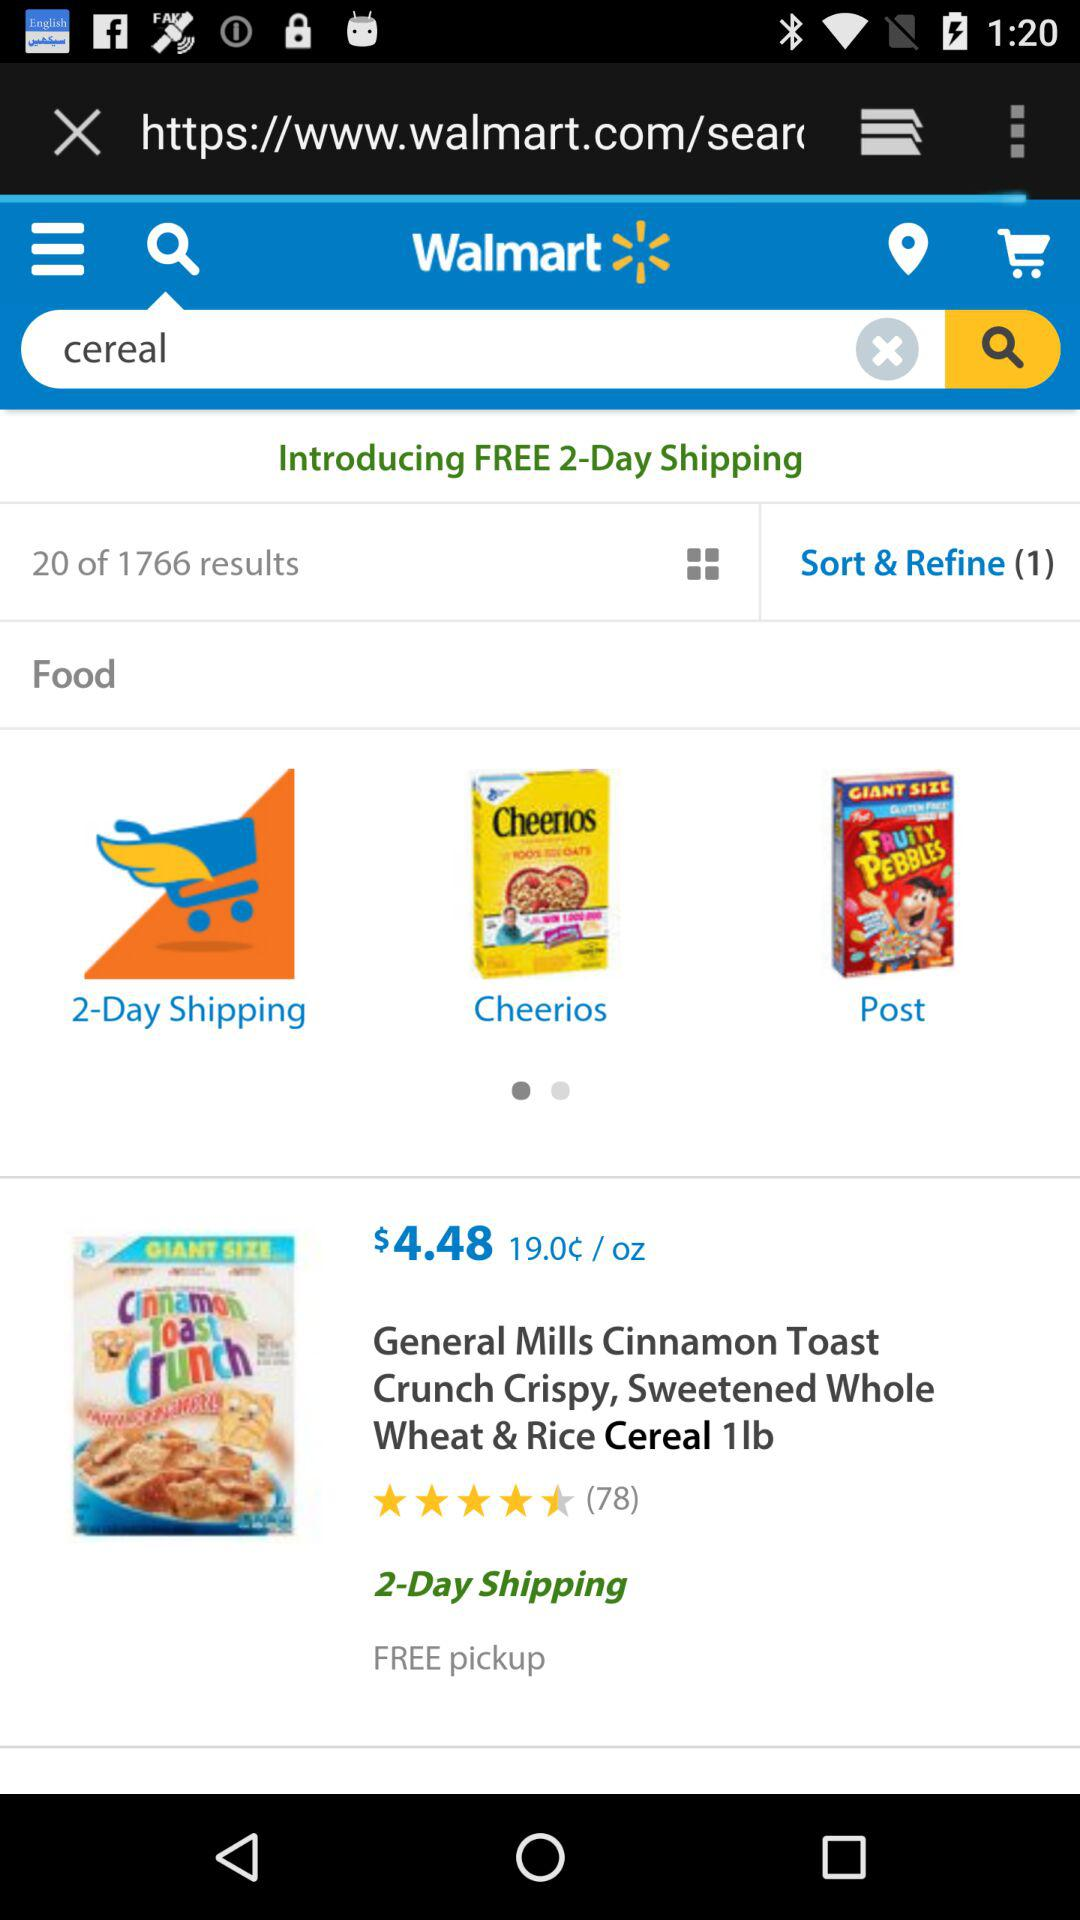What's the cost of 1 lb of cereal? The cost of 1 lb of cereal is $4.48. 